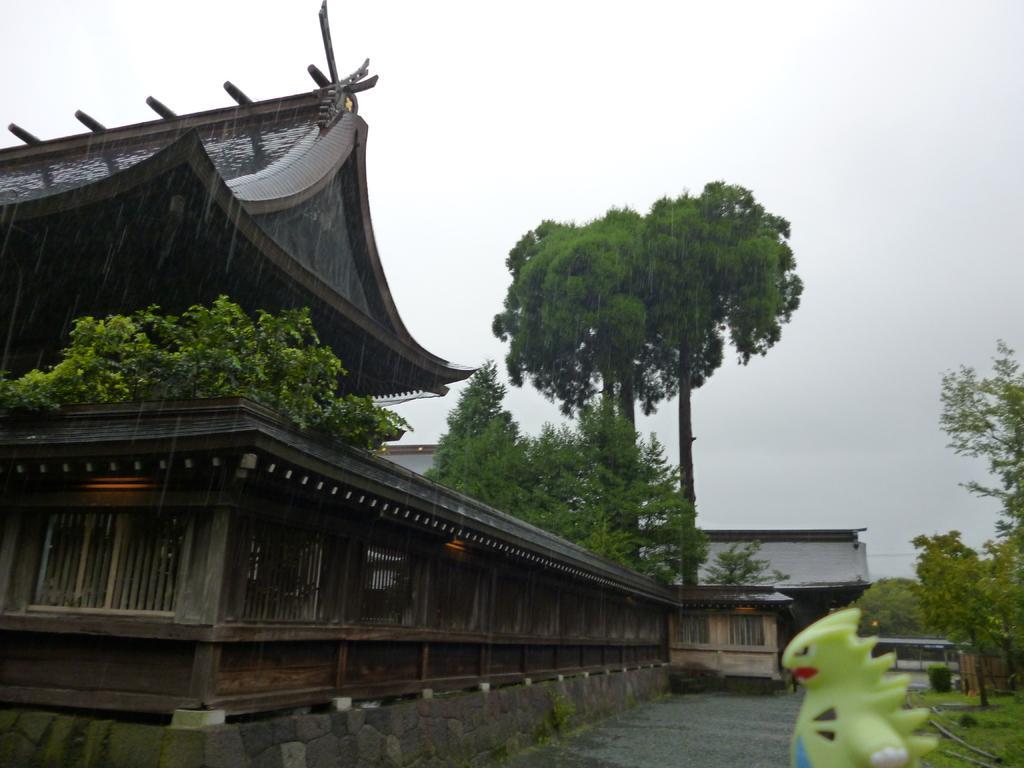Could you give a brief overview of what you see in this image? In this image we can see a building on the left side. Near to that there is a wooden fencing. Also there are trees. On the right side there are trees. On the ground there is grass. And there is a toy. In the background there are buildings and sky. And there is a road. Below the wooden fencing there is a brick wall. 